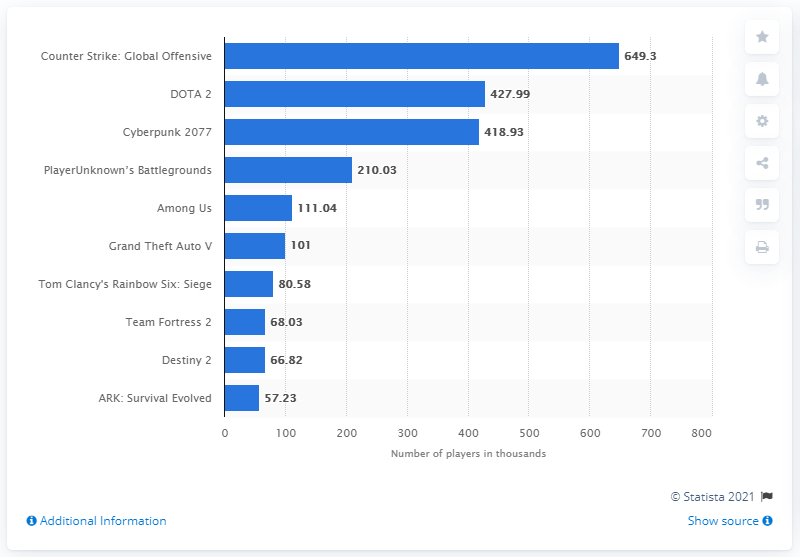Indicate a few pertinent items in this graphic. The second most popular game on Steam in 2020 was DOTA 2. According to statistics, the DOTA game that was ranked first in terms of average hours played by its players was Counter Strike: Global Offensive, with close to 650,000 hours on average. 